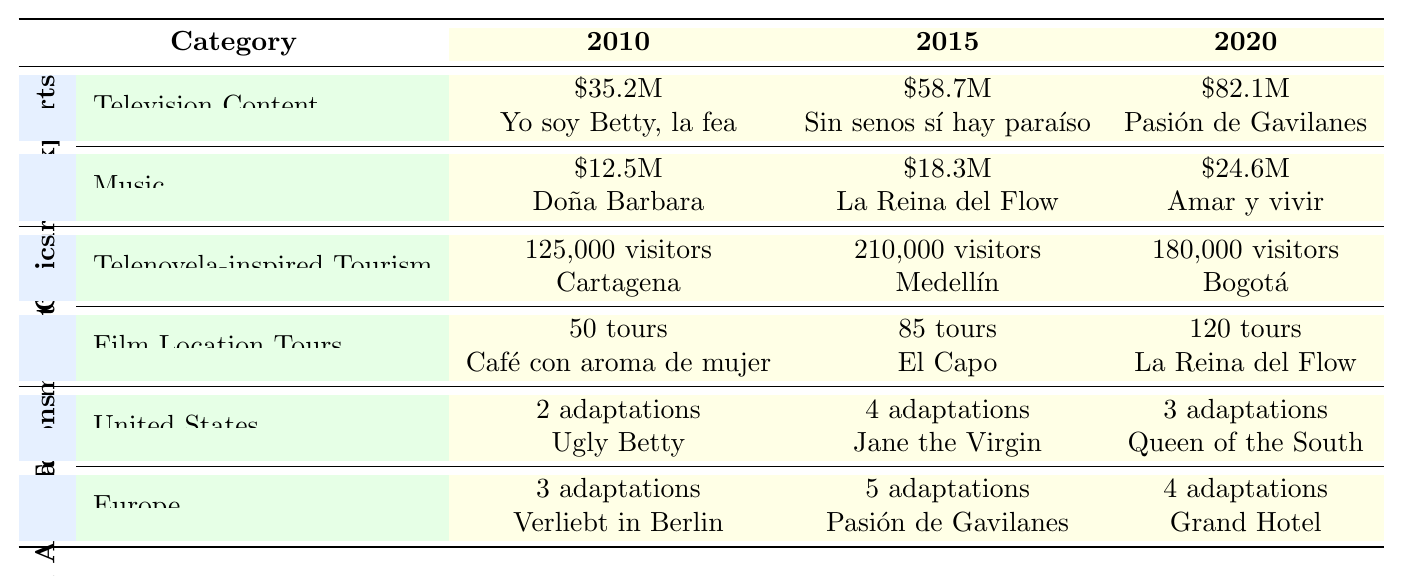What was the value of cultural exports from television content in 2020? The table indicates that the value of cultural exports from television content in 2020 is recorded as \$82.1 million.
Answer: \$82.1 million Which telenovela had the highest export value in 2015? In the table, the telenovela with the highest export value in 2015 is "Sin senos sí hay paraíso," which corresponds to the value of \$58.7 million.
Answer: Sin senos sí hay paraíso How much did music cultural exports increase from 2010 to 2020? The value for music cultural exports in 2010 is \$12.5 million, and in 2020 it is \$24.6 million. The increase is calculated as \$24.6 million - \$12.5 million = \$12.1 million.
Answer: \$12.1 million In which year did telenovela-inspired tourism have the highest number of visitors? The table shows that the year with the highest number of visitors due to telenovela-inspired tourism is 2015, with 210,000 visitors.
Answer: 2015 What was the total number of adaptations in the United States from 2010 to 2020? To find the total, we add the number of adaptations per year: 2 (2010) + 4 (2015) + 3 (2020) = 9 adaptations.
Answer: 9 adaptations Which telenovela soundtrack had the least export value in 2010? According to the table, the telenovela soundtrack with the least export value in 2010 is "Doña Barbara," which corresponds to a value of \$12.5 million.
Answer: Doña Barbara How many more adaptations were there in Europe than in the United States in 2015? In 2015, Europe had 5 adaptations and the United States had 4 adaptations. The difference is calculated as 5 - 4 = 1 adaptation more in Europe.
Answer: 1 adaptation What percentage of total visitors in 2020 were from telenovela-inspired tourism compared to film location tours? The number of visitors from telenovela-inspired tourism in 2020 is 180,000, and the number of film location tours is 120. First, we find the total visitors: 180,000 + 120 = 180,120. The percentage from telenovela-inspired tourism is (180,000 / 180,120) * 100 ≈ 99.9%.
Answer: 99.9% Which telenovela had the highest number of adaptations in Europe in 2015? The data shows that "Pasión de Gavilanes" had the highest number of adaptations in Europe in 2015 with a total of 5 adaptations.
Answer: Pasión de Gavilanes Was the number of film location tours greater in 2020 compared to 2010? Yes, the table indicates that there were 120 film location tours in 2020 compared to 50 in 2010, confirming that the number increased.
Answer: Yes 